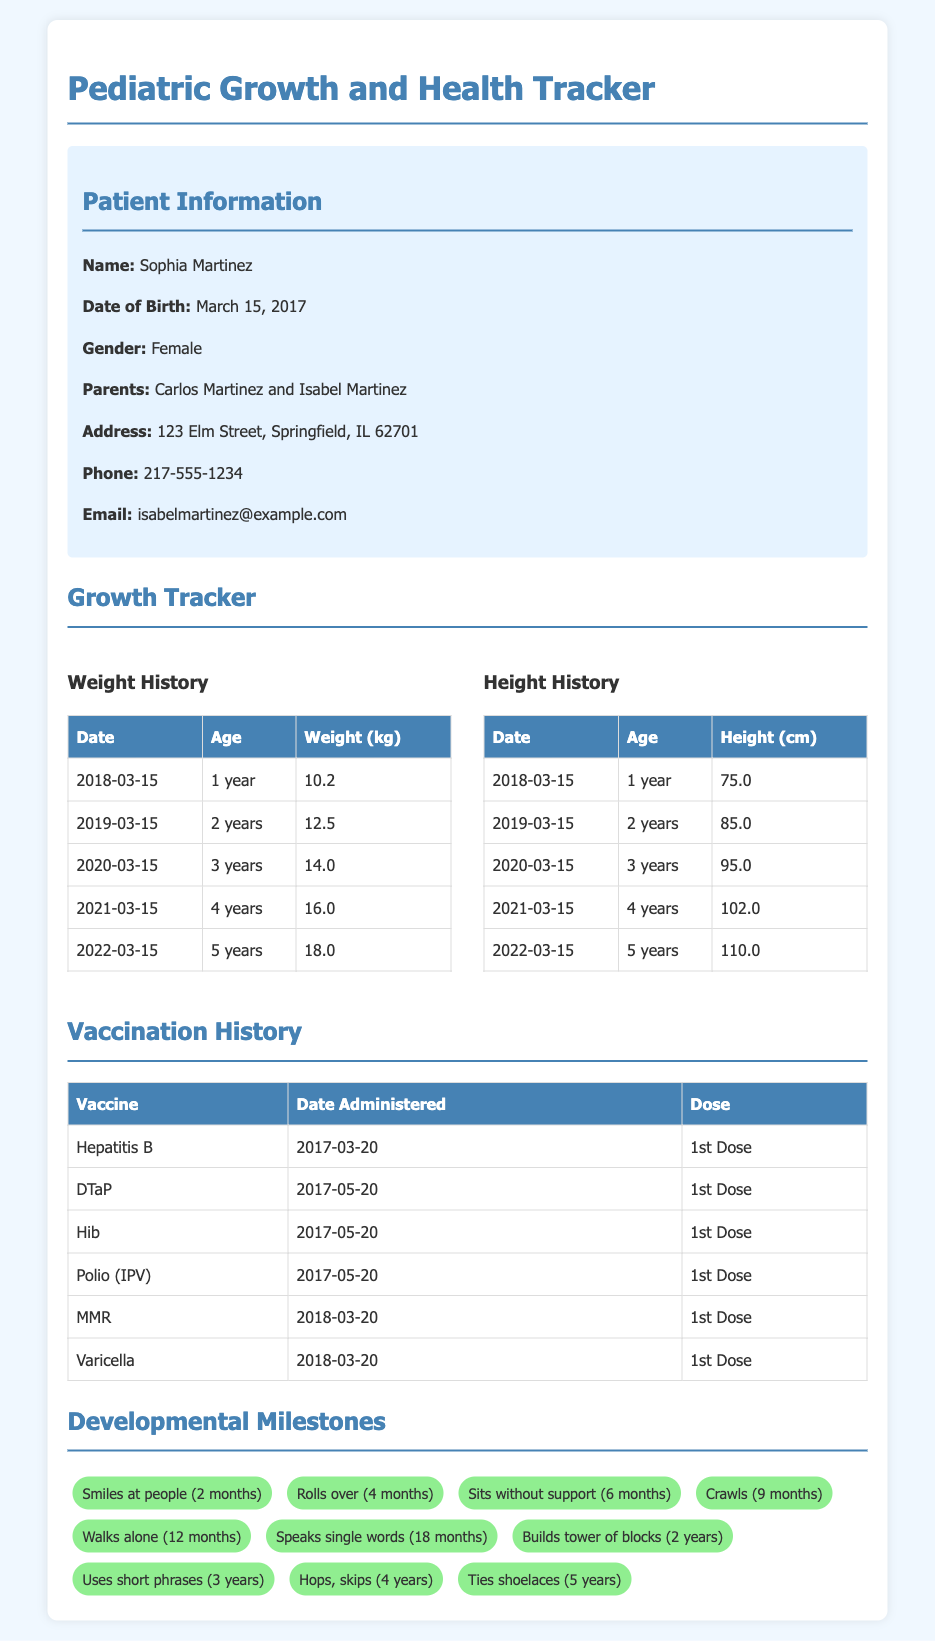What is the name of the patient? The name of the patient is listed in the patient information section.
Answer: Sophia Martinez What is the date of birth of the patient? The date of birth is provided under the patient information section.
Answer: March 15, 2017 What was the weight of the patient at 2 years old? The weight at each age is recorded in the weight history table.
Answer: 12.5 kg When was the first dose of the DTaP vaccine administered? The vaccination history lists the dates for each vaccine given.
Answer: 2017-05-20 What is one of the developmental milestones achieved at 4 years old? Developmental milestones are listed with the corresponding ages.
Answer: Hops, skips What is the height of the patient at 5 years old? The height at each age is recorded in the height history table.
Answer: 110.0 cm What is the address of the patients' family? The address is included in the patient information section.
Answer: 123 Elm Street, Springfield, IL 62701 What vaccine was administered on March 20, 2018? The vaccination history provides the names of vaccines and their administration dates.
Answer: MMR Which developmental milestone indicates that the child is 1 year old? The milestone list includes milestones achieved around 1 year of age.
Answer: Walks alone (12 months) 